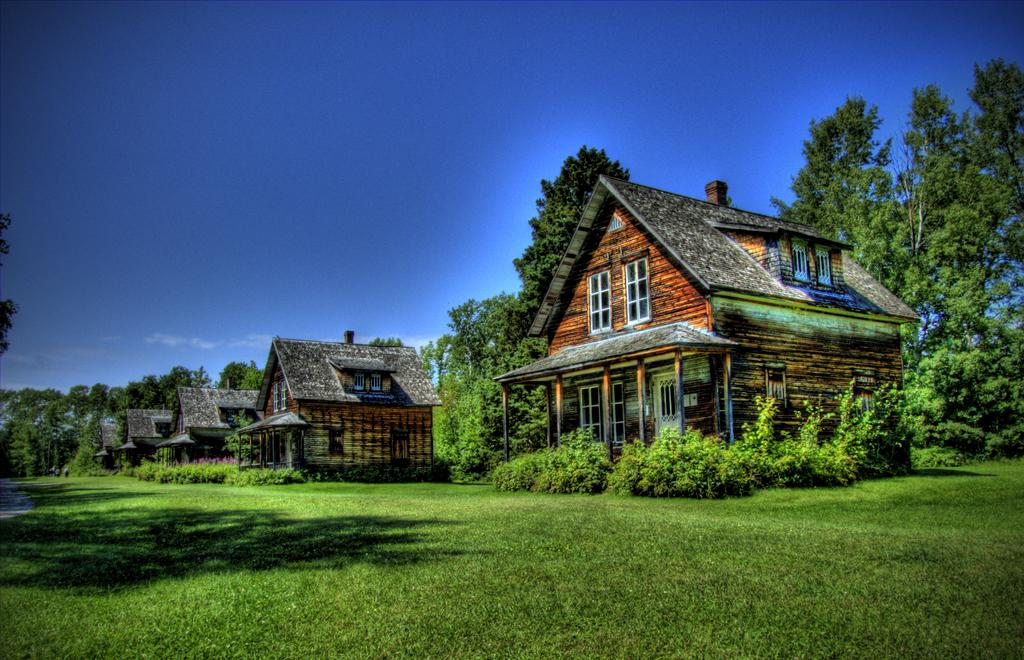What type of structures are on the ground in the image? There are cottages on the ground in the image. What type of vegetation is on the ground in the image? There is grass on the ground in the image. What other types of vegetation can be seen in the image? There are plants and trees in the image. What color is the sky in the background of the image? The sky is blue in the background of the image. What type of zipper can be seen on the trees in the image? There are no zippers present on the trees in the image. What company is responsible for maintaining the plants in the image? There is no information about a company responsible for maintaining the plants in the image. 